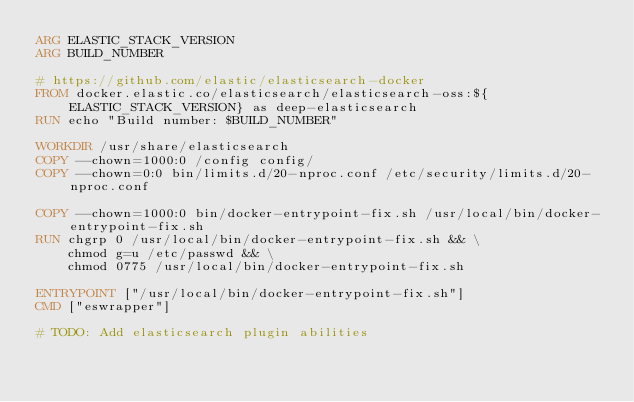Convert code to text. <code><loc_0><loc_0><loc_500><loc_500><_Dockerfile_>ARG ELASTIC_STACK_VERSION
ARG BUILD_NUMBER

# https://github.com/elastic/elasticsearch-docker
FROM docker.elastic.co/elasticsearch/elasticsearch-oss:${ELASTIC_STACK_VERSION} as deep-elasticsearch
RUN echo "Build number: $BUILD_NUMBER" 

WORKDIR /usr/share/elasticsearch
COPY --chown=1000:0 /config config/
COPY --chown=0:0 bin/limits.d/20-nproc.conf /etc/security/limits.d/20-nproc.conf

COPY --chown=1000:0 bin/docker-entrypoint-fix.sh /usr/local/bin/docker-entrypoint-fix.sh
RUN chgrp 0 /usr/local/bin/docker-entrypoint-fix.sh && \
    chmod g=u /etc/passwd && \
    chmod 0775 /usr/local/bin/docker-entrypoint-fix.sh

ENTRYPOINT ["/usr/local/bin/docker-entrypoint-fix.sh"]
CMD ["eswrapper"]

# TODO: Add elasticsearch plugin abilities</code> 